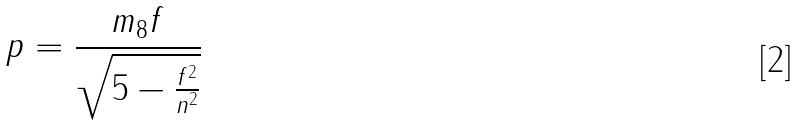Convert formula to latex. <formula><loc_0><loc_0><loc_500><loc_500>p = \frac { m _ { 8 } f } { \sqrt { 5 - \frac { f ^ { 2 } } { n ^ { 2 } } } }</formula> 